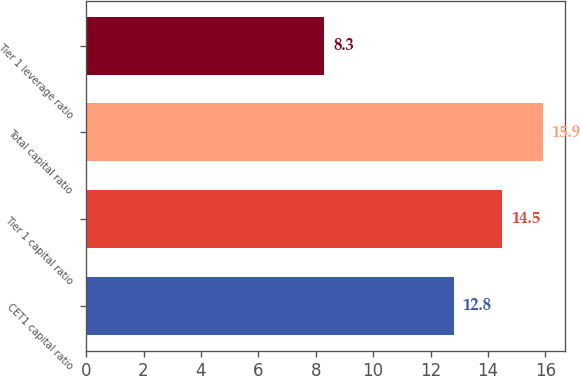Convert chart to OTSL. <chart><loc_0><loc_0><loc_500><loc_500><bar_chart><fcel>CET1 capital ratio<fcel>Tier 1 capital ratio<fcel>Total capital ratio<fcel>Tier 1 leverage ratio<nl><fcel>12.8<fcel>14.5<fcel>15.9<fcel>8.3<nl></chart> 